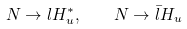Convert formula to latex. <formula><loc_0><loc_0><loc_500><loc_500>N \rightarrow l H _ { u } ^ { * } , \quad N \rightarrow \bar { l } H _ { u }</formula> 